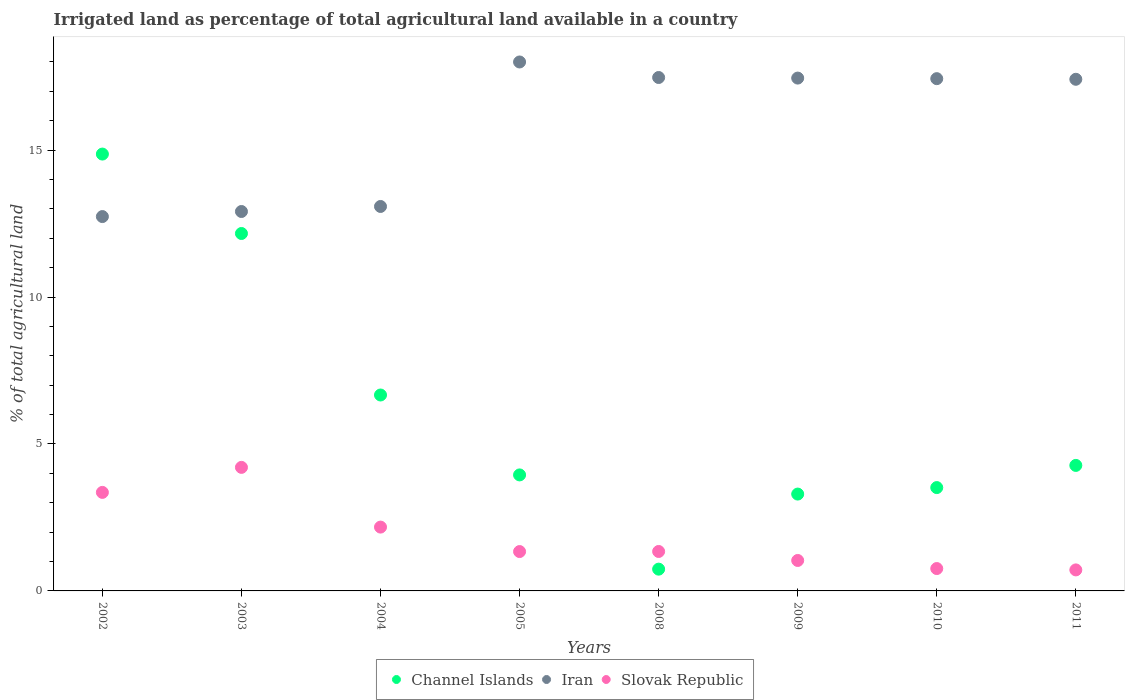Is the number of dotlines equal to the number of legend labels?
Provide a succinct answer. Yes. What is the percentage of irrigated land in Slovak Republic in 2009?
Your response must be concise. 1.04. Across all years, what is the maximum percentage of irrigated land in Iran?
Ensure brevity in your answer.  18. Across all years, what is the minimum percentage of irrigated land in Iran?
Your answer should be compact. 12.74. In which year was the percentage of irrigated land in Slovak Republic minimum?
Your response must be concise. 2011. What is the total percentage of irrigated land in Slovak Republic in the graph?
Offer a terse response. 14.92. What is the difference between the percentage of irrigated land in Channel Islands in 2002 and that in 2009?
Your answer should be very brief. 11.57. What is the difference between the percentage of irrigated land in Slovak Republic in 2011 and the percentage of irrigated land in Iran in 2010?
Provide a succinct answer. -16.72. What is the average percentage of irrigated land in Iran per year?
Make the answer very short. 15.81. In the year 2002, what is the difference between the percentage of irrigated land in Slovak Republic and percentage of irrigated land in Channel Islands?
Your answer should be compact. -11.51. What is the ratio of the percentage of irrigated land in Iran in 2003 to that in 2010?
Your answer should be compact. 0.74. Is the percentage of irrigated land in Slovak Republic in 2002 less than that in 2003?
Provide a short and direct response. Yes. Is the difference between the percentage of irrigated land in Slovak Republic in 2002 and 2005 greater than the difference between the percentage of irrigated land in Channel Islands in 2002 and 2005?
Your response must be concise. No. What is the difference between the highest and the second highest percentage of irrigated land in Slovak Republic?
Offer a very short reply. 0.85. What is the difference between the highest and the lowest percentage of irrigated land in Channel Islands?
Your response must be concise. 14.12. In how many years, is the percentage of irrigated land in Slovak Republic greater than the average percentage of irrigated land in Slovak Republic taken over all years?
Provide a short and direct response. 3. Is the sum of the percentage of irrigated land in Slovak Republic in 2004 and 2010 greater than the maximum percentage of irrigated land in Channel Islands across all years?
Provide a short and direct response. No. Is it the case that in every year, the sum of the percentage of irrigated land in Slovak Republic and percentage of irrigated land in Iran  is greater than the percentage of irrigated land in Channel Islands?
Your answer should be very brief. Yes. What is the difference between two consecutive major ticks on the Y-axis?
Offer a very short reply. 5. Are the values on the major ticks of Y-axis written in scientific E-notation?
Ensure brevity in your answer.  No. How many legend labels are there?
Your response must be concise. 3. What is the title of the graph?
Your answer should be very brief. Irrigated land as percentage of total agricultural land available in a country. What is the label or title of the X-axis?
Give a very brief answer. Years. What is the label or title of the Y-axis?
Give a very brief answer. % of total agricultural land. What is the % of total agricultural land in Channel Islands in 2002?
Your answer should be compact. 14.86. What is the % of total agricultural land of Iran in 2002?
Ensure brevity in your answer.  12.74. What is the % of total agricultural land of Slovak Republic in 2002?
Your answer should be very brief. 3.35. What is the % of total agricultural land in Channel Islands in 2003?
Provide a succinct answer. 12.16. What is the % of total agricultural land in Iran in 2003?
Offer a very short reply. 12.91. What is the % of total agricultural land of Slovak Republic in 2003?
Offer a very short reply. 4.2. What is the % of total agricultural land of Channel Islands in 2004?
Provide a succinct answer. 6.67. What is the % of total agricultural land of Iran in 2004?
Offer a very short reply. 13.08. What is the % of total agricultural land of Slovak Republic in 2004?
Your answer should be compact. 2.17. What is the % of total agricultural land in Channel Islands in 2005?
Make the answer very short. 3.95. What is the % of total agricultural land in Iran in 2005?
Provide a short and direct response. 18. What is the % of total agricultural land in Slovak Republic in 2005?
Your answer should be compact. 1.34. What is the % of total agricultural land of Channel Islands in 2008?
Provide a short and direct response. 0.74. What is the % of total agricultural land of Iran in 2008?
Make the answer very short. 17.47. What is the % of total agricultural land of Slovak Republic in 2008?
Give a very brief answer. 1.34. What is the % of total agricultural land in Channel Islands in 2009?
Keep it short and to the point. 3.3. What is the % of total agricultural land of Iran in 2009?
Give a very brief answer. 17.45. What is the % of total agricultural land of Slovak Republic in 2009?
Your answer should be very brief. 1.04. What is the % of total agricultural land of Channel Islands in 2010?
Keep it short and to the point. 3.52. What is the % of total agricultural land of Iran in 2010?
Provide a short and direct response. 17.43. What is the % of total agricultural land of Slovak Republic in 2010?
Offer a very short reply. 0.76. What is the % of total agricultural land in Channel Islands in 2011?
Ensure brevity in your answer.  4.27. What is the % of total agricultural land in Iran in 2011?
Offer a terse response. 17.41. What is the % of total agricultural land of Slovak Republic in 2011?
Your answer should be very brief. 0.72. Across all years, what is the maximum % of total agricultural land in Channel Islands?
Keep it short and to the point. 14.86. Across all years, what is the maximum % of total agricultural land of Iran?
Provide a short and direct response. 18. Across all years, what is the maximum % of total agricultural land in Slovak Republic?
Your answer should be very brief. 4.2. Across all years, what is the minimum % of total agricultural land in Channel Islands?
Give a very brief answer. 0.74. Across all years, what is the minimum % of total agricultural land of Iran?
Provide a succinct answer. 12.74. Across all years, what is the minimum % of total agricultural land of Slovak Republic?
Your response must be concise. 0.72. What is the total % of total agricultural land in Channel Islands in the graph?
Ensure brevity in your answer.  49.46. What is the total % of total agricultural land in Iran in the graph?
Keep it short and to the point. 126.49. What is the total % of total agricultural land of Slovak Republic in the graph?
Ensure brevity in your answer.  14.92. What is the difference between the % of total agricultural land of Channel Islands in 2002 and that in 2003?
Your answer should be very brief. 2.7. What is the difference between the % of total agricultural land in Iran in 2002 and that in 2003?
Ensure brevity in your answer.  -0.17. What is the difference between the % of total agricultural land in Slovak Republic in 2002 and that in 2003?
Your answer should be compact. -0.85. What is the difference between the % of total agricultural land in Channel Islands in 2002 and that in 2004?
Provide a succinct answer. 8.2. What is the difference between the % of total agricultural land of Iran in 2002 and that in 2004?
Make the answer very short. -0.34. What is the difference between the % of total agricultural land in Slovak Republic in 2002 and that in 2004?
Provide a short and direct response. 1.18. What is the difference between the % of total agricultural land in Channel Islands in 2002 and that in 2005?
Your answer should be compact. 10.92. What is the difference between the % of total agricultural land in Iran in 2002 and that in 2005?
Provide a succinct answer. -5.26. What is the difference between the % of total agricultural land of Slovak Republic in 2002 and that in 2005?
Ensure brevity in your answer.  2.01. What is the difference between the % of total agricultural land of Channel Islands in 2002 and that in 2008?
Provide a succinct answer. 14.12. What is the difference between the % of total agricultural land in Iran in 2002 and that in 2008?
Keep it short and to the point. -4.73. What is the difference between the % of total agricultural land in Slovak Republic in 2002 and that in 2008?
Keep it short and to the point. 2.01. What is the difference between the % of total agricultural land in Channel Islands in 2002 and that in 2009?
Your answer should be compact. 11.57. What is the difference between the % of total agricultural land in Iran in 2002 and that in 2009?
Give a very brief answer. -4.71. What is the difference between the % of total agricultural land in Slovak Republic in 2002 and that in 2009?
Give a very brief answer. 2.32. What is the difference between the % of total agricultural land of Channel Islands in 2002 and that in 2010?
Keep it short and to the point. 11.35. What is the difference between the % of total agricultural land in Iran in 2002 and that in 2010?
Make the answer very short. -4.69. What is the difference between the % of total agricultural land of Slovak Republic in 2002 and that in 2010?
Your answer should be compact. 2.59. What is the difference between the % of total agricultural land in Channel Islands in 2002 and that in 2011?
Provide a short and direct response. 10.59. What is the difference between the % of total agricultural land of Iran in 2002 and that in 2011?
Your answer should be compact. -4.67. What is the difference between the % of total agricultural land in Slovak Republic in 2002 and that in 2011?
Give a very brief answer. 2.64. What is the difference between the % of total agricultural land of Channel Islands in 2003 and that in 2004?
Keep it short and to the point. 5.5. What is the difference between the % of total agricultural land of Iran in 2003 and that in 2004?
Provide a succinct answer. -0.17. What is the difference between the % of total agricultural land in Slovak Republic in 2003 and that in 2004?
Offer a terse response. 2.03. What is the difference between the % of total agricultural land in Channel Islands in 2003 and that in 2005?
Keep it short and to the point. 8.21. What is the difference between the % of total agricultural land of Iran in 2003 and that in 2005?
Offer a very short reply. -5.09. What is the difference between the % of total agricultural land of Slovak Republic in 2003 and that in 2005?
Ensure brevity in your answer.  2.86. What is the difference between the % of total agricultural land in Channel Islands in 2003 and that in 2008?
Give a very brief answer. 11.42. What is the difference between the % of total agricultural land in Iran in 2003 and that in 2008?
Ensure brevity in your answer.  -4.56. What is the difference between the % of total agricultural land in Slovak Republic in 2003 and that in 2008?
Provide a short and direct response. 2.86. What is the difference between the % of total agricultural land in Channel Islands in 2003 and that in 2009?
Make the answer very short. 8.87. What is the difference between the % of total agricultural land of Iran in 2003 and that in 2009?
Provide a succinct answer. -4.54. What is the difference between the % of total agricultural land in Slovak Republic in 2003 and that in 2009?
Give a very brief answer. 3.17. What is the difference between the % of total agricultural land in Channel Islands in 2003 and that in 2010?
Give a very brief answer. 8.65. What is the difference between the % of total agricultural land in Iran in 2003 and that in 2010?
Make the answer very short. -4.52. What is the difference between the % of total agricultural land in Slovak Republic in 2003 and that in 2010?
Your response must be concise. 3.44. What is the difference between the % of total agricultural land of Channel Islands in 2003 and that in 2011?
Offer a very short reply. 7.89. What is the difference between the % of total agricultural land in Iran in 2003 and that in 2011?
Offer a terse response. -4.5. What is the difference between the % of total agricultural land in Slovak Republic in 2003 and that in 2011?
Provide a short and direct response. 3.49. What is the difference between the % of total agricultural land in Channel Islands in 2004 and that in 2005?
Keep it short and to the point. 2.72. What is the difference between the % of total agricultural land in Iran in 2004 and that in 2005?
Your answer should be compact. -4.92. What is the difference between the % of total agricultural land in Slovak Republic in 2004 and that in 2005?
Give a very brief answer. 0.83. What is the difference between the % of total agricultural land in Channel Islands in 2004 and that in 2008?
Give a very brief answer. 5.93. What is the difference between the % of total agricultural land of Iran in 2004 and that in 2008?
Offer a terse response. -4.39. What is the difference between the % of total agricultural land in Slovak Republic in 2004 and that in 2008?
Your response must be concise. 0.83. What is the difference between the % of total agricultural land in Channel Islands in 2004 and that in 2009?
Your response must be concise. 3.37. What is the difference between the % of total agricultural land in Iran in 2004 and that in 2009?
Provide a succinct answer. -4.37. What is the difference between the % of total agricultural land of Slovak Republic in 2004 and that in 2009?
Give a very brief answer. 1.14. What is the difference between the % of total agricultural land in Channel Islands in 2004 and that in 2010?
Your answer should be very brief. 3.15. What is the difference between the % of total agricultural land in Iran in 2004 and that in 2010?
Make the answer very short. -4.35. What is the difference between the % of total agricultural land of Slovak Republic in 2004 and that in 2010?
Your answer should be compact. 1.41. What is the difference between the % of total agricultural land of Channel Islands in 2004 and that in 2011?
Provide a short and direct response. 2.4. What is the difference between the % of total agricultural land of Iran in 2004 and that in 2011?
Give a very brief answer. -4.33. What is the difference between the % of total agricultural land of Slovak Republic in 2004 and that in 2011?
Provide a short and direct response. 1.46. What is the difference between the % of total agricultural land in Channel Islands in 2005 and that in 2008?
Make the answer very short. 3.21. What is the difference between the % of total agricultural land in Iran in 2005 and that in 2008?
Provide a succinct answer. 0.53. What is the difference between the % of total agricultural land of Slovak Republic in 2005 and that in 2008?
Ensure brevity in your answer.  -0. What is the difference between the % of total agricultural land in Channel Islands in 2005 and that in 2009?
Your answer should be compact. 0.65. What is the difference between the % of total agricultural land in Iran in 2005 and that in 2009?
Provide a succinct answer. 0.55. What is the difference between the % of total agricultural land of Slovak Republic in 2005 and that in 2009?
Offer a terse response. 0.3. What is the difference between the % of total agricultural land in Channel Islands in 2005 and that in 2010?
Ensure brevity in your answer.  0.43. What is the difference between the % of total agricultural land of Iran in 2005 and that in 2010?
Your response must be concise. 0.57. What is the difference between the % of total agricultural land of Slovak Republic in 2005 and that in 2010?
Give a very brief answer. 0.58. What is the difference between the % of total agricultural land in Channel Islands in 2005 and that in 2011?
Offer a terse response. -0.32. What is the difference between the % of total agricultural land of Iran in 2005 and that in 2011?
Provide a short and direct response. 0.59. What is the difference between the % of total agricultural land of Slovak Republic in 2005 and that in 2011?
Provide a succinct answer. 0.62. What is the difference between the % of total agricultural land of Channel Islands in 2008 and that in 2009?
Make the answer very short. -2.55. What is the difference between the % of total agricultural land of Iran in 2008 and that in 2009?
Offer a very short reply. 0.02. What is the difference between the % of total agricultural land in Slovak Republic in 2008 and that in 2009?
Give a very brief answer. 0.31. What is the difference between the % of total agricultural land of Channel Islands in 2008 and that in 2010?
Offer a terse response. -2.78. What is the difference between the % of total agricultural land of Iran in 2008 and that in 2010?
Your response must be concise. 0.04. What is the difference between the % of total agricultural land in Slovak Republic in 2008 and that in 2010?
Your answer should be compact. 0.58. What is the difference between the % of total agricultural land of Channel Islands in 2008 and that in 2011?
Provide a short and direct response. -3.53. What is the difference between the % of total agricultural land of Iran in 2008 and that in 2011?
Keep it short and to the point. 0.06. What is the difference between the % of total agricultural land in Slovak Republic in 2008 and that in 2011?
Offer a terse response. 0.63. What is the difference between the % of total agricultural land of Channel Islands in 2009 and that in 2010?
Provide a succinct answer. -0.22. What is the difference between the % of total agricultural land in Iran in 2009 and that in 2010?
Your answer should be compact. 0.02. What is the difference between the % of total agricultural land in Slovak Republic in 2009 and that in 2010?
Keep it short and to the point. 0.28. What is the difference between the % of total agricultural land in Channel Islands in 2009 and that in 2011?
Your answer should be compact. -0.98. What is the difference between the % of total agricultural land of Iran in 2009 and that in 2011?
Offer a very short reply. 0.04. What is the difference between the % of total agricultural land of Slovak Republic in 2009 and that in 2011?
Provide a succinct answer. 0.32. What is the difference between the % of total agricultural land of Channel Islands in 2010 and that in 2011?
Provide a succinct answer. -0.75. What is the difference between the % of total agricultural land in Iran in 2010 and that in 2011?
Your answer should be compact. 0.02. What is the difference between the % of total agricultural land of Slovak Republic in 2010 and that in 2011?
Offer a very short reply. 0.05. What is the difference between the % of total agricultural land in Channel Islands in 2002 and the % of total agricultural land in Iran in 2003?
Ensure brevity in your answer.  1.95. What is the difference between the % of total agricultural land in Channel Islands in 2002 and the % of total agricultural land in Slovak Republic in 2003?
Your response must be concise. 10.66. What is the difference between the % of total agricultural land of Iran in 2002 and the % of total agricultural land of Slovak Republic in 2003?
Provide a succinct answer. 8.53. What is the difference between the % of total agricultural land of Channel Islands in 2002 and the % of total agricultural land of Iran in 2004?
Give a very brief answer. 1.78. What is the difference between the % of total agricultural land in Channel Islands in 2002 and the % of total agricultural land in Slovak Republic in 2004?
Give a very brief answer. 12.69. What is the difference between the % of total agricultural land in Iran in 2002 and the % of total agricultural land in Slovak Republic in 2004?
Your answer should be compact. 10.57. What is the difference between the % of total agricultural land of Channel Islands in 2002 and the % of total agricultural land of Iran in 2005?
Your answer should be compact. -3.13. What is the difference between the % of total agricultural land in Channel Islands in 2002 and the % of total agricultural land in Slovak Republic in 2005?
Ensure brevity in your answer.  13.53. What is the difference between the % of total agricultural land of Iran in 2002 and the % of total agricultural land of Slovak Republic in 2005?
Keep it short and to the point. 11.4. What is the difference between the % of total agricultural land of Channel Islands in 2002 and the % of total agricultural land of Iran in 2008?
Provide a short and direct response. -2.61. What is the difference between the % of total agricultural land of Channel Islands in 2002 and the % of total agricultural land of Slovak Republic in 2008?
Offer a very short reply. 13.52. What is the difference between the % of total agricultural land of Iran in 2002 and the % of total agricultural land of Slovak Republic in 2008?
Give a very brief answer. 11.4. What is the difference between the % of total agricultural land in Channel Islands in 2002 and the % of total agricultural land in Iran in 2009?
Make the answer very short. -2.59. What is the difference between the % of total agricultural land in Channel Islands in 2002 and the % of total agricultural land in Slovak Republic in 2009?
Keep it short and to the point. 13.83. What is the difference between the % of total agricultural land of Iran in 2002 and the % of total agricultural land of Slovak Republic in 2009?
Your answer should be compact. 11.7. What is the difference between the % of total agricultural land in Channel Islands in 2002 and the % of total agricultural land in Iran in 2010?
Offer a very short reply. -2.57. What is the difference between the % of total agricultural land in Channel Islands in 2002 and the % of total agricultural land in Slovak Republic in 2010?
Provide a succinct answer. 14.1. What is the difference between the % of total agricultural land in Iran in 2002 and the % of total agricultural land in Slovak Republic in 2010?
Provide a short and direct response. 11.98. What is the difference between the % of total agricultural land of Channel Islands in 2002 and the % of total agricultural land of Iran in 2011?
Make the answer very short. -2.54. What is the difference between the % of total agricultural land of Channel Islands in 2002 and the % of total agricultural land of Slovak Republic in 2011?
Keep it short and to the point. 14.15. What is the difference between the % of total agricultural land in Iran in 2002 and the % of total agricultural land in Slovak Republic in 2011?
Offer a terse response. 12.02. What is the difference between the % of total agricultural land of Channel Islands in 2003 and the % of total agricultural land of Iran in 2004?
Give a very brief answer. -0.92. What is the difference between the % of total agricultural land of Channel Islands in 2003 and the % of total agricultural land of Slovak Republic in 2004?
Provide a succinct answer. 9.99. What is the difference between the % of total agricultural land of Iran in 2003 and the % of total agricultural land of Slovak Republic in 2004?
Your answer should be compact. 10.74. What is the difference between the % of total agricultural land in Channel Islands in 2003 and the % of total agricultural land in Iran in 2005?
Give a very brief answer. -5.84. What is the difference between the % of total agricultural land of Channel Islands in 2003 and the % of total agricultural land of Slovak Republic in 2005?
Provide a succinct answer. 10.82. What is the difference between the % of total agricultural land in Iran in 2003 and the % of total agricultural land in Slovak Republic in 2005?
Your response must be concise. 11.57. What is the difference between the % of total agricultural land of Channel Islands in 2003 and the % of total agricultural land of Iran in 2008?
Your answer should be very brief. -5.31. What is the difference between the % of total agricultural land of Channel Islands in 2003 and the % of total agricultural land of Slovak Republic in 2008?
Your response must be concise. 10.82. What is the difference between the % of total agricultural land in Iran in 2003 and the % of total agricultural land in Slovak Republic in 2008?
Your answer should be very brief. 11.57. What is the difference between the % of total agricultural land in Channel Islands in 2003 and the % of total agricultural land in Iran in 2009?
Provide a short and direct response. -5.29. What is the difference between the % of total agricultural land of Channel Islands in 2003 and the % of total agricultural land of Slovak Republic in 2009?
Provide a succinct answer. 11.13. What is the difference between the % of total agricultural land of Iran in 2003 and the % of total agricultural land of Slovak Republic in 2009?
Keep it short and to the point. 11.87. What is the difference between the % of total agricultural land of Channel Islands in 2003 and the % of total agricultural land of Iran in 2010?
Offer a terse response. -5.27. What is the difference between the % of total agricultural land of Channel Islands in 2003 and the % of total agricultural land of Slovak Republic in 2010?
Give a very brief answer. 11.4. What is the difference between the % of total agricultural land in Iran in 2003 and the % of total agricultural land in Slovak Republic in 2010?
Your answer should be very brief. 12.15. What is the difference between the % of total agricultural land of Channel Islands in 2003 and the % of total agricultural land of Iran in 2011?
Ensure brevity in your answer.  -5.25. What is the difference between the % of total agricultural land of Channel Islands in 2003 and the % of total agricultural land of Slovak Republic in 2011?
Your answer should be very brief. 11.45. What is the difference between the % of total agricultural land in Iran in 2003 and the % of total agricultural land in Slovak Republic in 2011?
Offer a terse response. 12.2. What is the difference between the % of total agricultural land in Channel Islands in 2004 and the % of total agricultural land in Iran in 2005?
Give a very brief answer. -11.33. What is the difference between the % of total agricultural land in Channel Islands in 2004 and the % of total agricultural land in Slovak Republic in 2005?
Keep it short and to the point. 5.33. What is the difference between the % of total agricultural land of Iran in 2004 and the % of total agricultural land of Slovak Republic in 2005?
Provide a succinct answer. 11.74. What is the difference between the % of total agricultural land of Channel Islands in 2004 and the % of total agricultural land of Iran in 2008?
Your answer should be very brief. -10.8. What is the difference between the % of total agricultural land of Channel Islands in 2004 and the % of total agricultural land of Slovak Republic in 2008?
Your answer should be compact. 5.32. What is the difference between the % of total agricultural land of Iran in 2004 and the % of total agricultural land of Slovak Republic in 2008?
Offer a very short reply. 11.74. What is the difference between the % of total agricultural land of Channel Islands in 2004 and the % of total agricultural land of Iran in 2009?
Keep it short and to the point. -10.78. What is the difference between the % of total agricultural land of Channel Islands in 2004 and the % of total agricultural land of Slovak Republic in 2009?
Make the answer very short. 5.63. What is the difference between the % of total agricultural land in Iran in 2004 and the % of total agricultural land in Slovak Republic in 2009?
Provide a short and direct response. 12.05. What is the difference between the % of total agricultural land in Channel Islands in 2004 and the % of total agricultural land in Iran in 2010?
Ensure brevity in your answer.  -10.76. What is the difference between the % of total agricultural land in Channel Islands in 2004 and the % of total agricultural land in Slovak Republic in 2010?
Offer a very short reply. 5.91. What is the difference between the % of total agricultural land of Iran in 2004 and the % of total agricultural land of Slovak Republic in 2010?
Offer a terse response. 12.32. What is the difference between the % of total agricultural land in Channel Islands in 2004 and the % of total agricultural land in Iran in 2011?
Your answer should be very brief. -10.74. What is the difference between the % of total agricultural land of Channel Islands in 2004 and the % of total agricultural land of Slovak Republic in 2011?
Make the answer very short. 5.95. What is the difference between the % of total agricultural land in Iran in 2004 and the % of total agricultural land in Slovak Republic in 2011?
Your response must be concise. 12.37. What is the difference between the % of total agricultural land of Channel Islands in 2005 and the % of total agricultural land of Iran in 2008?
Offer a very short reply. -13.52. What is the difference between the % of total agricultural land in Channel Islands in 2005 and the % of total agricultural land in Slovak Republic in 2008?
Ensure brevity in your answer.  2.61. What is the difference between the % of total agricultural land of Iran in 2005 and the % of total agricultural land of Slovak Republic in 2008?
Give a very brief answer. 16.66. What is the difference between the % of total agricultural land in Channel Islands in 2005 and the % of total agricultural land in Iran in 2009?
Offer a very short reply. -13.5. What is the difference between the % of total agricultural land in Channel Islands in 2005 and the % of total agricultural land in Slovak Republic in 2009?
Provide a succinct answer. 2.91. What is the difference between the % of total agricultural land in Iran in 2005 and the % of total agricultural land in Slovak Republic in 2009?
Keep it short and to the point. 16.96. What is the difference between the % of total agricultural land of Channel Islands in 2005 and the % of total agricultural land of Iran in 2010?
Offer a terse response. -13.48. What is the difference between the % of total agricultural land of Channel Islands in 2005 and the % of total agricultural land of Slovak Republic in 2010?
Your answer should be compact. 3.19. What is the difference between the % of total agricultural land of Iran in 2005 and the % of total agricultural land of Slovak Republic in 2010?
Make the answer very short. 17.24. What is the difference between the % of total agricultural land of Channel Islands in 2005 and the % of total agricultural land of Iran in 2011?
Make the answer very short. -13.46. What is the difference between the % of total agricultural land in Channel Islands in 2005 and the % of total agricultural land in Slovak Republic in 2011?
Keep it short and to the point. 3.23. What is the difference between the % of total agricultural land in Iran in 2005 and the % of total agricultural land in Slovak Republic in 2011?
Your answer should be compact. 17.28. What is the difference between the % of total agricultural land of Channel Islands in 2008 and the % of total agricultural land of Iran in 2009?
Offer a terse response. -16.71. What is the difference between the % of total agricultural land of Channel Islands in 2008 and the % of total agricultural land of Slovak Republic in 2009?
Provide a succinct answer. -0.3. What is the difference between the % of total agricultural land of Iran in 2008 and the % of total agricultural land of Slovak Republic in 2009?
Provide a succinct answer. 16.43. What is the difference between the % of total agricultural land of Channel Islands in 2008 and the % of total agricultural land of Iran in 2010?
Give a very brief answer. -16.69. What is the difference between the % of total agricultural land in Channel Islands in 2008 and the % of total agricultural land in Slovak Republic in 2010?
Offer a terse response. -0.02. What is the difference between the % of total agricultural land of Iran in 2008 and the % of total agricultural land of Slovak Republic in 2010?
Provide a short and direct response. 16.71. What is the difference between the % of total agricultural land of Channel Islands in 2008 and the % of total agricultural land of Iran in 2011?
Offer a terse response. -16.67. What is the difference between the % of total agricultural land in Channel Islands in 2008 and the % of total agricultural land in Slovak Republic in 2011?
Provide a succinct answer. 0.03. What is the difference between the % of total agricultural land of Iran in 2008 and the % of total agricultural land of Slovak Republic in 2011?
Your response must be concise. 16.76. What is the difference between the % of total agricultural land of Channel Islands in 2009 and the % of total agricultural land of Iran in 2010?
Your response must be concise. -14.14. What is the difference between the % of total agricultural land of Channel Islands in 2009 and the % of total agricultural land of Slovak Republic in 2010?
Your answer should be compact. 2.53. What is the difference between the % of total agricultural land of Iran in 2009 and the % of total agricultural land of Slovak Republic in 2010?
Offer a very short reply. 16.69. What is the difference between the % of total agricultural land in Channel Islands in 2009 and the % of total agricultural land in Iran in 2011?
Offer a very short reply. -14.11. What is the difference between the % of total agricultural land in Channel Islands in 2009 and the % of total agricultural land in Slovak Republic in 2011?
Your answer should be compact. 2.58. What is the difference between the % of total agricultural land in Iran in 2009 and the % of total agricultural land in Slovak Republic in 2011?
Offer a terse response. 16.74. What is the difference between the % of total agricultural land of Channel Islands in 2010 and the % of total agricultural land of Iran in 2011?
Your answer should be compact. -13.89. What is the difference between the % of total agricultural land in Channel Islands in 2010 and the % of total agricultural land in Slovak Republic in 2011?
Your response must be concise. 2.8. What is the difference between the % of total agricultural land in Iran in 2010 and the % of total agricultural land in Slovak Republic in 2011?
Offer a very short reply. 16.72. What is the average % of total agricultural land in Channel Islands per year?
Your answer should be compact. 6.18. What is the average % of total agricultural land of Iran per year?
Your answer should be very brief. 15.81. What is the average % of total agricultural land of Slovak Republic per year?
Ensure brevity in your answer.  1.87. In the year 2002, what is the difference between the % of total agricultural land in Channel Islands and % of total agricultural land in Iran?
Offer a very short reply. 2.13. In the year 2002, what is the difference between the % of total agricultural land in Channel Islands and % of total agricultural land in Slovak Republic?
Your answer should be very brief. 11.51. In the year 2002, what is the difference between the % of total agricultural land in Iran and % of total agricultural land in Slovak Republic?
Make the answer very short. 9.39. In the year 2003, what is the difference between the % of total agricultural land of Channel Islands and % of total agricultural land of Iran?
Offer a very short reply. -0.75. In the year 2003, what is the difference between the % of total agricultural land in Channel Islands and % of total agricultural land in Slovak Republic?
Provide a succinct answer. 7.96. In the year 2003, what is the difference between the % of total agricultural land of Iran and % of total agricultural land of Slovak Republic?
Offer a terse response. 8.71. In the year 2004, what is the difference between the % of total agricultural land of Channel Islands and % of total agricultural land of Iran?
Your answer should be very brief. -6.42. In the year 2004, what is the difference between the % of total agricultural land of Channel Islands and % of total agricultural land of Slovak Republic?
Provide a succinct answer. 4.5. In the year 2004, what is the difference between the % of total agricultural land of Iran and % of total agricultural land of Slovak Republic?
Give a very brief answer. 10.91. In the year 2005, what is the difference between the % of total agricultural land of Channel Islands and % of total agricultural land of Iran?
Offer a very short reply. -14.05. In the year 2005, what is the difference between the % of total agricultural land in Channel Islands and % of total agricultural land in Slovak Republic?
Your answer should be compact. 2.61. In the year 2005, what is the difference between the % of total agricultural land in Iran and % of total agricultural land in Slovak Republic?
Provide a succinct answer. 16.66. In the year 2008, what is the difference between the % of total agricultural land in Channel Islands and % of total agricultural land in Iran?
Give a very brief answer. -16.73. In the year 2008, what is the difference between the % of total agricultural land in Channel Islands and % of total agricultural land in Slovak Republic?
Provide a short and direct response. -0.6. In the year 2008, what is the difference between the % of total agricultural land of Iran and % of total agricultural land of Slovak Republic?
Offer a terse response. 16.13. In the year 2009, what is the difference between the % of total agricultural land of Channel Islands and % of total agricultural land of Iran?
Offer a terse response. -14.15. In the year 2009, what is the difference between the % of total agricultural land of Channel Islands and % of total agricultural land of Slovak Republic?
Your answer should be compact. 2.26. In the year 2009, what is the difference between the % of total agricultural land of Iran and % of total agricultural land of Slovak Republic?
Your answer should be compact. 16.41. In the year 2010, what is the difference between the % of total agricultural land in Channel Islands and % of total agricultural land in Iran?
Provide a short and direct response. -13.91. In the year 2010, what is the difference between the % of total agricultural land in Channel Islands and % of total agricultural land in Slovak Republic?
Your answer should be very brief. 2.76. In the year 2010, what is the difference between the % of total agricultural land in Iran and % of total agricultural land in Slovak Republic?
Give a very brief answer. 16.67. In the year 2011, what is the difference between the % of total agricultural land of Channel Islands and % of total agricultural land of Iran?
Give a very brief answer. -13.14. In the year 2011, what is the difference between the % of total agricultural land of Channel Islands and % of total agricultural land of Slovak Republic?
Your answer should be very brief. 3.56. In the year 2011, what is the difference between the % of total agricultural land in Iran and % of total agricultural land in Slovak Republic?
Provide a succinct answer. 16.69. What is the ratio of the % of total agricultural land of Channel Islands in 2002 to that in 2003?
Make the answer very short. 1.22. What is the ratio of the % of total agricultural land in Iran in 2002 to that in 2003?
Offer a very short reply. 0.99. What is the ratio of the % of total agricultural land of Slovak Republic in 2002 to that in 2003?
Provide a short and direct response. 0.8. What is the ratio of the % of total agricultural land in Channel Islands in 2002 to that in 2004?
Ensure brevity in your answer.  2.23. What is the ratio of the % of total agricultural land of Iran in 2002 to that in 2004?
Ensure brevity in your answer.  0.97. What is the ratio of the % of total agricultural land in Slovak Republic in 2002 to that in 2004?
Ensure brevity in your answer.  1.54. What is the ratio of the % of total agricultural land of Channel Islands in 2002 to that in 2005?
Give a very brief answer. 3.77. What is the ratio of the % of total agricultural land in Iran in 2002 to that in 2005?
Your answer should be very brief. 0.71. What is the ratio of the % of total agricultural land in Slovak Republic in 2002 to that in 2005?
Make the answer very short. 2.5. What is the ratio of the % of total agricultural land in Channel Islands in 2002 to that in 2008?
Provide a succinct answer. 20.07. What is the ratio of the % of total agricultural land in Iran in 2002 to that in 2008?
Your answer should be very brief. 0.73. What is the ratio of the % of total agricultural land in Slovak Republic in 2002 to that in 2008?
Your response must be concise. 2.5. What is the ratio of the % of total agricultural land of Channel Islands in 2002 to that in 2009?
Make the answer very short. 4.51. What is the ratio of the % of total agricultural land of Iran in 2002 to that in 2009?
Your answer should be very brief. 0.73. What is the ratio of the % of total agricultural land of Slovak Republic in 2002 to that in 2009?
Your answer should be compact. 3.24. What is the ratio of the % of total agricultural land of Channel Islands in 2002 to that in 2010?
Your response must be concise. 4.23. What is the ratio of the % of total agricultural land of Iran in 2002 to that in 2010?
Ensure brevity in your answer.  0.73. What is the ratio of the % of total agricultural land in Slovak Republic in 2002 to that in 2010?
Your response must be concise. 4.41. What is the ratio of the % of total agricultural land of Channel Islands in 2002 to that in 2011?
Offer a terse response. 3.48. What is the ratio of the % of total agricultural land of Iran in 2002 to that in 2011?
Provide a short and direct response. 0.73. What is the ratio of the % of total agricultural land in Slovak Republic in 2002 to that in 2011?
Keep it short and to the point. 4.69. What is the ratio of the % of total agricultural land in Channel Islands in 2003 to that in 2004?
Your response must be concise. 1.82. What is the ratio of the % of total agricultural land of Iran in 2003 to that in 2004?
Keep it short and to the point. 0.99. What is the ratio of the % of total agricultural land of Slovak Republic in 2003 to that in 2004?
Offer a very short reply. 1.94. What is the ratio of the % of total agricultural land in Channel Islands in 2003 to that in 2005?
Your response must be concise. 3.08. What is the ratio of the % of total agricultural land of Iran in 2003 to that in 2005?
Your answer should be very brief. 0.72. What is the ratio of the % of total agricultural land of Slovak Republic in 2003 to that in 2005?
Ensure brevity in your answer.  3.14. What is the ratio of the % of total agricultural land in Channel Islands in 2003 to that in 2008?
Offer a very short reply. 16.42. What is the ratio of the % of total agricultural land of Iran in 2003 to that in 2008?
Provide a succinct answer. 0.74. What is the ratio of the % of total agricultural land in Slovak Republic in 2003 to that in 2008?
Offer a terse response. 3.13. What is the ratio of the % of total agricultural land in Channel Islands in 2003 to that in 2009?
Give a very brief answer. 3.69. What is the ratio of the % of total agricultural land of Iran in 2003 to that in 2009?
Offer a very short reply. 0.74. What is the ratio of the % of total agricultural land of Slovak Republic in 2003 to that in 2009?
Your response must be concise. 4.06. What is the ratio of the % of total agricultural land of Channel Islands in 2003 to that in 2010?
Offer a terse response. 3.46. What is the ratio of the % of total agricultural land of Iran in 2003 to that in 2010?
Your answer should be very brief. 0.74. What is the ratio of the % of total agricultural land of Slovak Republic in 2003 to that in 2010?
Keep it short and to the point. 5.52. What is the ratio of the % of total agricultural land in Channel Islands in 2003 to that in 2011?
Your answer should be very brief. 2.85. What is the ratio of the % of total agricultural land in Iran in 2003 to that in 2011?
Your answer should be compact. 0.74. What is the ratio of the % of total agricultural land of Slovak Republic in 2003 to that in 2011?
Provide a succinct answer. 5.88. What is the ratio of the % of total agricultural land in Channel Islands in 2004 to that in 2005?
Your response must be concise. 1.69. What is the ratio of the % of total agricultural land in Iran in 2004 to that in 2005?
Provide a short and direct response. 0.73. What is the ratio of the % of total agricultural land in Slovak Republic in 2004 to that in 2005?
Provide a short and direct response. 1.62. What is the ratio of the % of total agricultural land in Channel Islands in 2004 to that in 2008?
Your answer should be very brief. 9. What is the ratio of the % of total agricultural land in Iran in 2004 to that in 2008?
Keep it short and to the point. 0.75. What is the ratio of the % of total agricultural land of Slovak Republic in 2004 to that in 2008?
Ensure brevity in your answer.  1.62. What is the ratio of the % of total agricultural land in Channel Islands in 2004 to that in 2009?
Make the answer very short. 2.02. What is the ratio of the % of total agricultural land in Iran in 2004 to that in 2009?
Keep it short and to the point. 0.75. What is the ratio of the % of total agricultural land of Slovak Republic in 2004 to that in 2009?
Offer a terse response. 2.1. What is the ratio of the % of total agricultural land of Channel Islands in 2004 to that in 2010?
Keep it short and to the point. 1.9. What is the ratio of the % of total agricultural land in Iran in 2004 to that in 2010?
Provide a succinct answer. 0.75. What is the ratio of the % of total agricultural land of Slovak Republic in 2004 to that in 2010?
Ensure brevity in your answer.  2.85. What is the ratio of the % of total agricultural land of Channel Islands in 2004 to that in 2011?
Offer a terse response. 1.56. What is the ratio of the % of total agricultural land of Iran in 2004 to that in 2011?
Ensure brevity in your answer.  0.75. What is the ratio of the % of total agricultural land in Slovak Republic in 2004 to that in 2011?
Offer a terse response. 3.04. What is the ratio of the % of total agricultural land in Channel Islands in 2005 to that in 2008?
Offer a very short reply. 5.33. What is the ratio of the % of total agricultural land in Iran in 2005 to that in 2008?
Provide a succinct answer. 1.03. What is the ratio of the % of total agricultural land of Slovak Republic in 2005 to that in 2008?
Your answer should be compact. 1. What is the ratio of the % of total agricultural land in Channel Islands in 2005 to that in 2009?
Offer a terse response. 1.2. What is the ratio of the % of total agricultural land in Iran in 2005 to that in 2009?
Provide a short and direct response. 1.03. What is the ratio of the % of total agricultural land in Slovak Republic in 2005 to that in 2009?
Your answer should be very brief. 1.29. What is the ratio of the % of total agricultural land in Channel Islands in 2005 to that in 2010?
Make the answer very short. 1.12. What is the ratio of the % of total agricultural land in Iran in 2005 to that in 2010?
Give a very brief answer. 1.03. What is the ratio of the % of total agricultural land in Slovak Republic in 2005 to that in 2010?
Make the answer very short. 1.76. What is the ratio of the % of total agricultural land in Channel Islands in 2005 to that in 2011?
Your response must be concise. 0.92. What is the ratio of the % of total agricultural land of Iran in 2005 to that in 2011?
Your response must be concise. 1.03. What is the ratio of the % of total agricultural land in Slovak Republic in 2005 to that in 2011?
Offer a terse response. 1.87. What is the ratio of the % of total agricultural land of Channel Islands in 2008 to that in 2009?
Your response must be concise. 0.22. What is the ratio of the % of total agricultural land in Iran in 2008 to that in 2009?
Ensure brevity in your answer.  1. What is the ratio of the % of total agricultural land of Slovak Republic in 2008 to that in 2009?
Your response must be concise. 1.3. What is the ratio of the % of total agricultural land of Channel Islands in 2008 to that in 2010?
Give a very brief answer. 0.21. What is the ratio of the % of total agricultural land of Iran in 2008 to that in 2010?
Ensure brevity in your answer.  1. What is the ratio of the % of total agricultural land of Slovak Republic in 2008 to that in 2010?
Your answer should be compact. 1.76. What is the ratio of the % of total agricultural land of Channel Islands in 2008 to that in 2011?
Your answer should be compact. 0.17. What is the ratio of the % of total agricultural land in Slovak Republic in 2008 to that in 2011?
Ensure brevity in your answer.  1.88. What is the ratio of the % of total agricultural land in Channel Islands in 2009 to that in 2010?
Offer a very short reply. 0.94. What is the ratio of the % of total agricultural land of Slovak Republic in 2009 to that in 2010?
Your response must be concise. 1.36. What is the ratio of the % of total agricultural land of Channel Islands in 2009 to that in 2011?
Your response must be concise. 0.77. What is the ratio of the % of total agricultural land of Iran in 2009 to that in 2011?
Ensure brevity in your answer.  1. What is the ratio of the % of total agricultural land in Slovak Republic in 2009 to that in 2011?
Give a very brief answer. 1.45. What is the ratio of the % of total agricultural land of Channel Islands in 2010 to that in 2011?
Your response must be concise. 0.82. What is the ratio of the % of total agricultural land in Slovak Republic in 2010 to that in 2011?
Your answer should be compact. 1.06. What is the difference between the highest and the second highest % of total agricultural land of Channel Islands?
Ensure brevity in your answer.  2.7. What is the difference between the highest and the second highest % of total agricultural land of Iran?
Your answer should be compact. 0.53. What is the difference between the highest and the second highest % of total agricultural land of Slovak Republic?
Your answer should be compact. 0.85. What is the difference between the highest and the lowest % of total agricultural land of Channel Islands?
Your response must be concise. 14.12. What is the difference between the highest and the lowest % of total agricultural land in Iran?
Ensure brevity in your answer.  5.26. What is the difference between the highest and the lowest % of total agricultural land in Slovak Republic?
Provide a succinct answer. 3.49. 